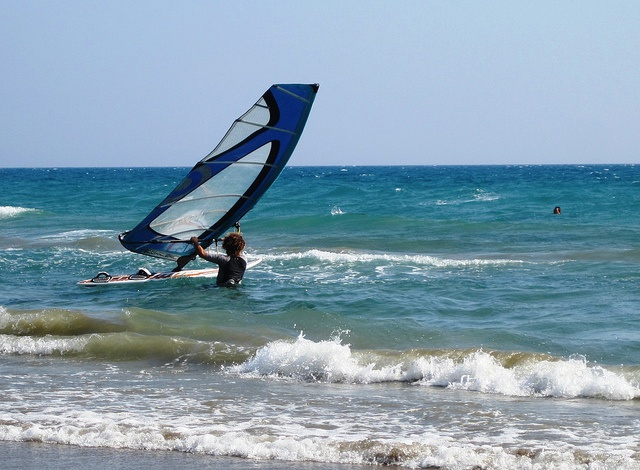Describe the objects in this image and their specific colors. I can see people in lightblue, black, gray, maroon, and darkgray tones, surfboard in lightblue, lightgray, gray, black, and darkgray tones, and people in lightblue, black, blue, gray, and maroon tones in this image. 